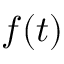Convert formula to latex. <formula><loc_0><loc_0><loc_500><loc_500>f ( t )</formula> 